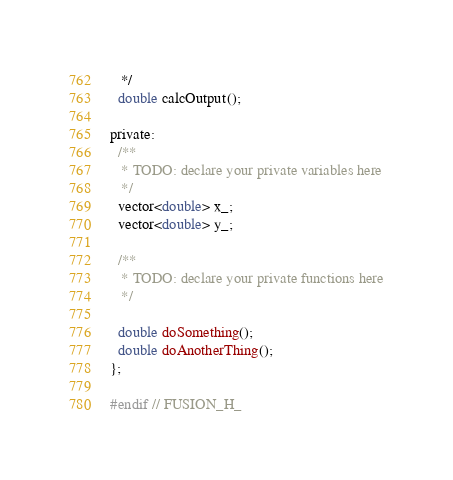<code> <loc_0><loc_0><loc_500><loc_500><_C_>   */
  double calcOutput();

private:
  /**
   * TODO: declare your private variables here
   */
  vector<double> x_;
  vector<double> y_;

  /**
   * TODO: declare your private functions here
   */

  double doSomething();
  double doAnotherThing();
};

#endif // FUSION_H_</code> 